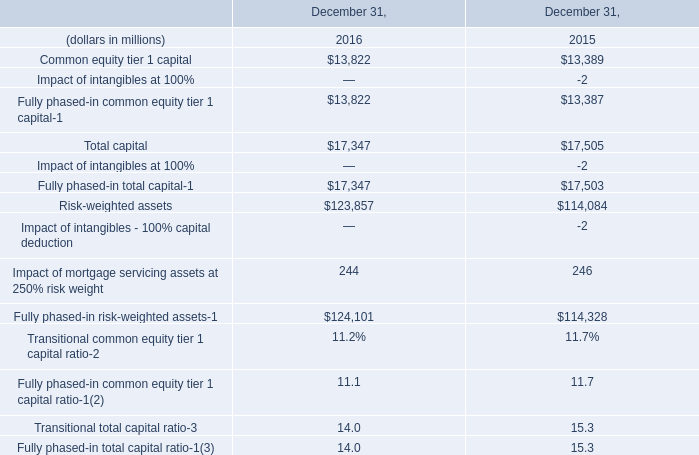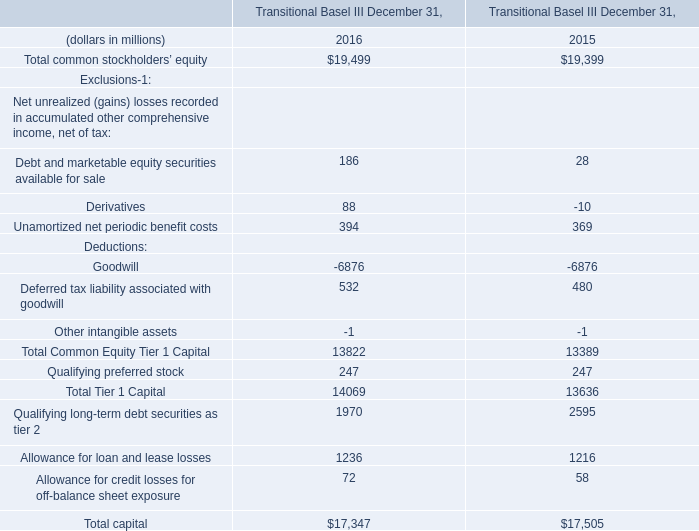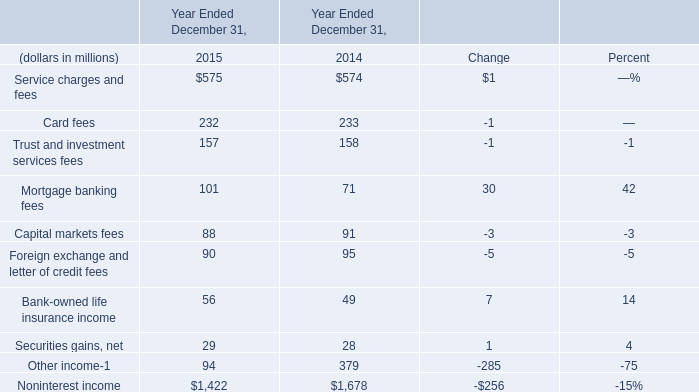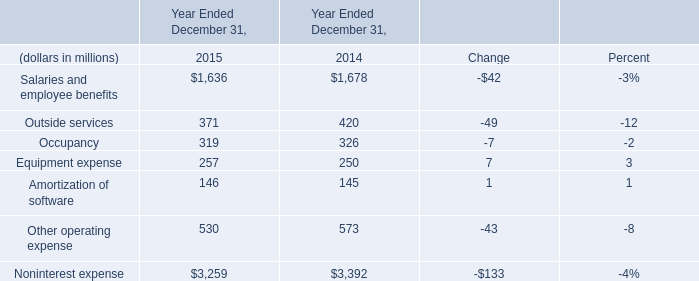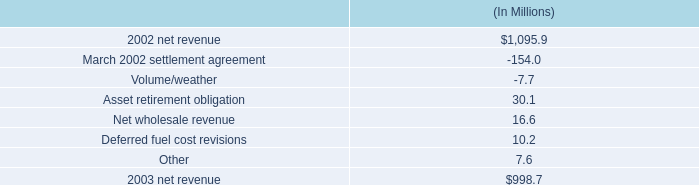In the year with the most equipment expense, what is the growth rate of outside services? 
Computations: ((371 - 420) / 420)
Answer: -0.11667. 